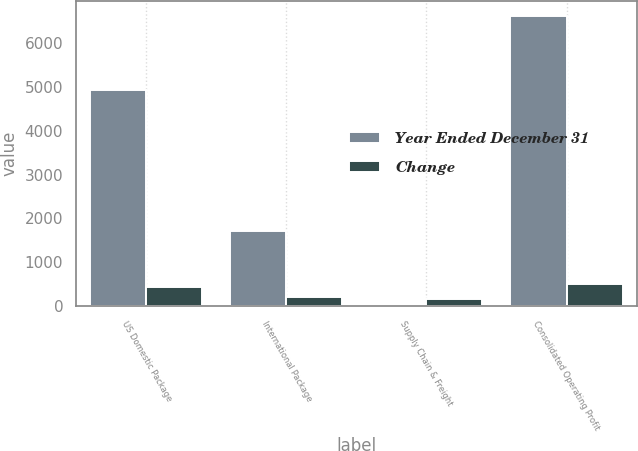<chart> <loc_0><loc_0><loc_500><loc_500><stacked_bar_chart><ecel><fcel>US Domestic Package<fcel>International Package<fcel>Supply Chain & Freight<fcel>Consolidated Operating Profit<nl><fcel>Year Ended December 31<fcel>4923<fcel>1710<fcel>2<fcel>6635<nl><fcel>Change<fcel>430<fcel>216<fcel>154<fcel>492<nl></chart> 